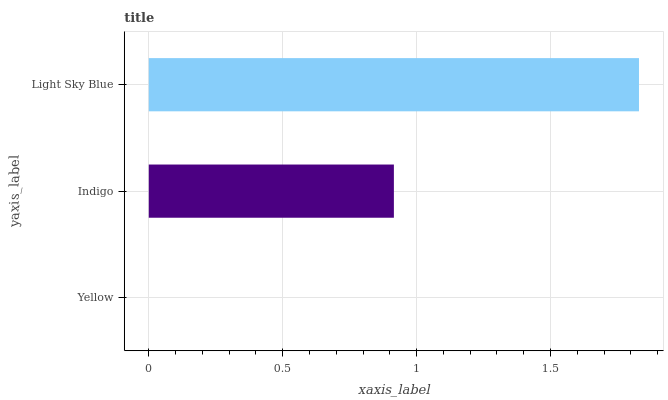Is Yellow the minimum?
Answer yes or no. Yes. Is Light Sky Blue the maximum?
Answer yes or no. Yes. Is Indigo the minimum?
Answer yes or no. No. Is Indigo the maximum?
Answer yes or no. No. Is Indigo greater than Yellow?
Answer yes or no. Yes. Is Yellow less than Indigo?
Answer yes or no. Yes. Is Yellow greater than Indigo?
Answer yes or no. No. Is Indigo less than Yellow?
Answer yes or no. No. Is Indigo the high median?
Answer yes or no. Yes. Is Indigo the low median?
Answer yes or no. Yes. Is Light Sky Blue the high median?
Answer yes or no. No. Is Light Sky Blue the low median?
Answer yes or no. No. 